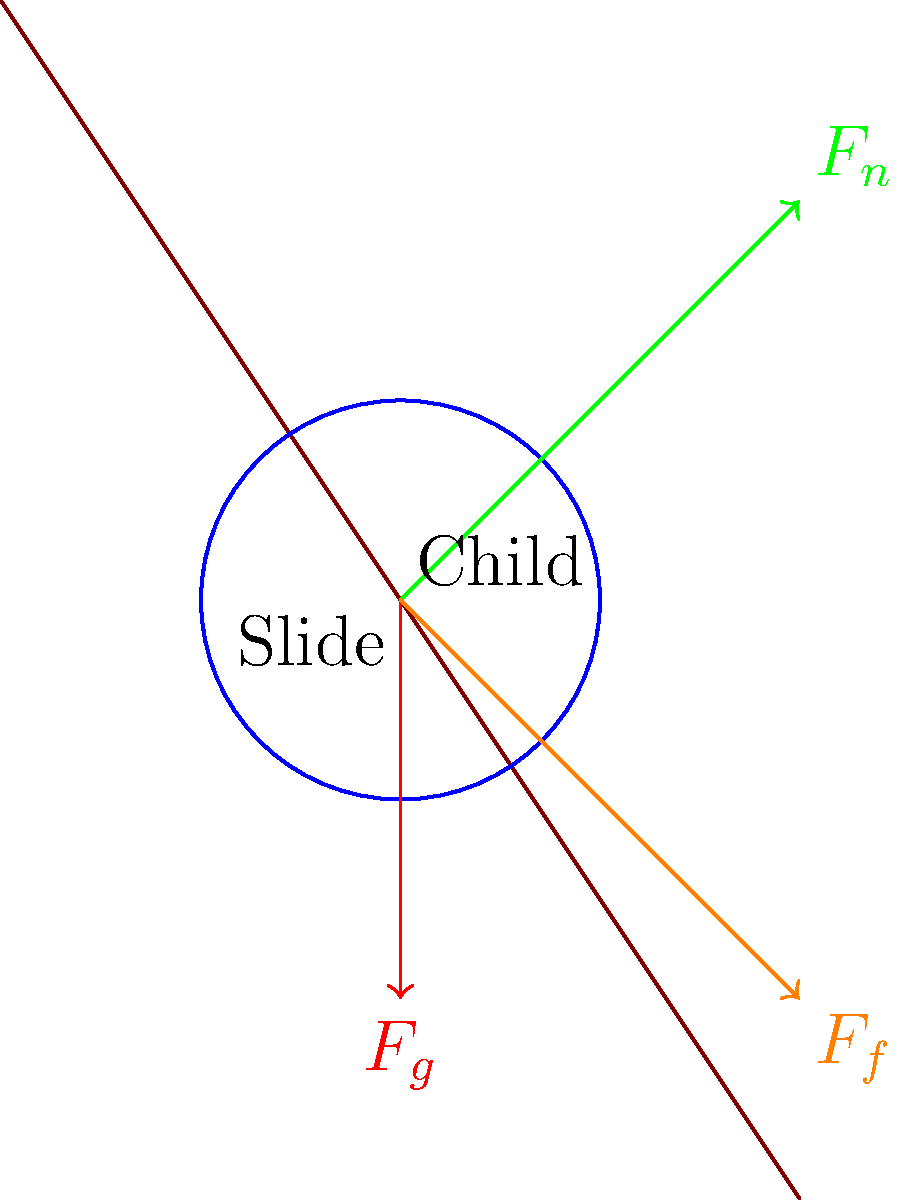As your child slides down a playground slide, consider the forces acting on their knee joint. The image shows a simplified force diagram of the situation. What is the primary force that opposes the child's motion down the slide, and how does it relate to the normal force? Let's break this down step-by-step:

1. The forces acting on the child's knee joint are:
   - Gravitational force ($F_g$): Pulling the child downward
   - Normal force ($F_n$): The force exerted by the slide surface perpendicular to it
   - Friction force ($F_f$): Acting opposite to the direction of motion

2. The primary force opposing the child's motion down the slide is the friction force ($F_f$).

3. The friction force is related to the normal force through the equation:

   $$F_f = \mu F_n$$

   Where $\mu$ is the coefficient of friction between the child's clothing and the slide surface.

4. The normal force ($F_n$) is perpendicular to the slide surface and is a component of the child's weight. As the normal force increases, so does the friction force.

5. The friction force is what allows the child to slide at a controlled speed rather than accelerating rapidly down the slide.

6. In this context, understanding the relationship between friction and the normal force is crucial for playground safety, as it affects how fast children descend slides and the potential for injuries.
Answer: Friction force; directly proportional to normal force 